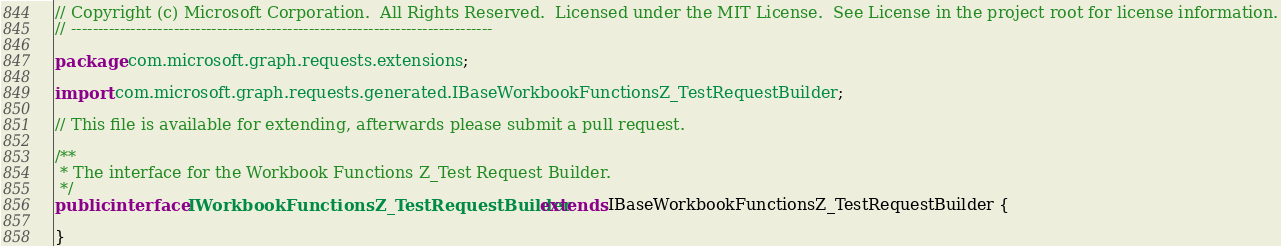Convert code to text. <code><loc_0><loc_0><loc_500><loc_500><_Java_>// Copyright (c) Microsoft Corporation.  All Rights Reserved.  Licensed under the MIT License.  See License in the project root for license information.
// ------------------------------------------------------------------------------

package com.microsoft.graph.requests.extensions;

import com.microsoft.graph.requests.generated.IBaseWorkbookFunctionsZ_TestRequestBuilder;

// This file is available for extending, afterwards please submit a pull request.

/**
 * The interface for the Workbook Functions Z_Test Request Builder.
 */
public interface IWorkbookFunctionsZ_TestRequestBuilder extends IBaseWorkbookFunctionsZ_TestRequestBuilder {

}
</code> 